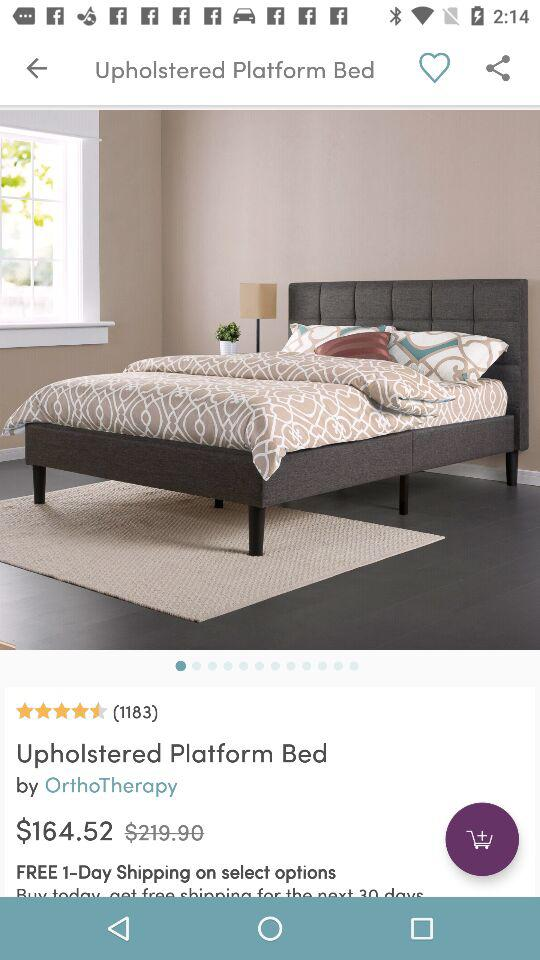What is the price of the bed? The price of the bed is $164.52. 